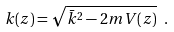<formula> <loc_0><loc_0><loc_500><loc_500>k ( z ) = \sqrt { \bar { k } ^ { 2 } - 2 m V ( z ) } \ .</formula> 